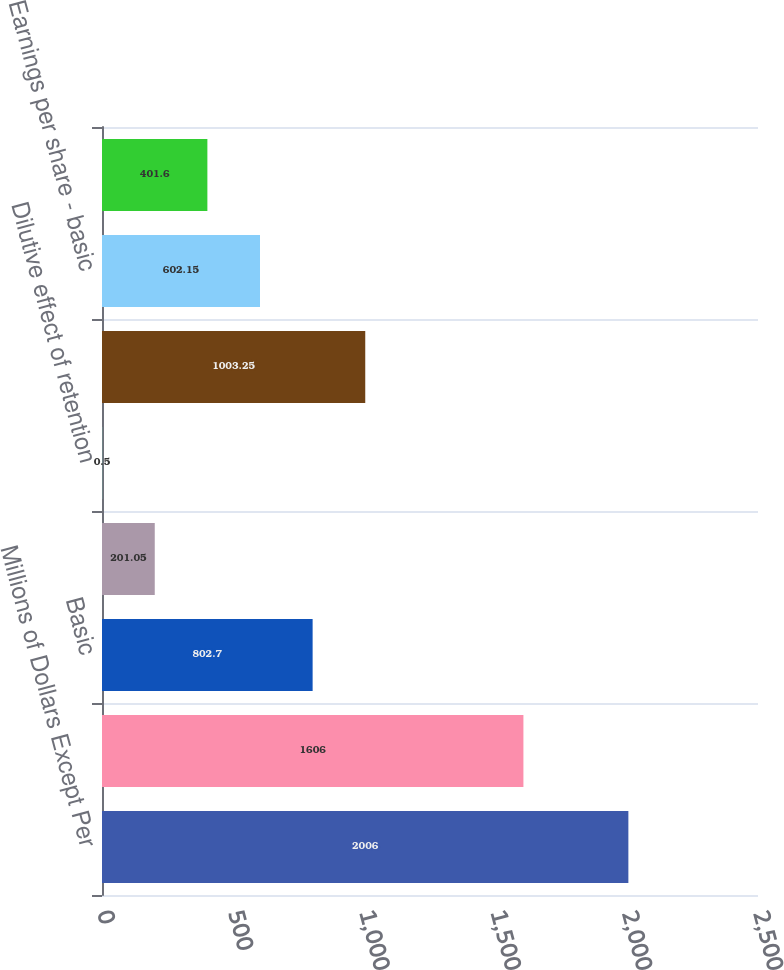<chart> <loc_0><loc_0><loc_500><loc_500><bar_chart><fcel>Millions of Dollars Except Per<fcel>Net income<fcel>Basic<fcel>Dilutive effect of stock<fcel>Dilutive effect of retention<fcel>Diluted<fcel>Earnings per share - basic<fcel>Earnings per share - diluted<nl><fcel>2006<fcel>1606<fcel>802.7<fcel>201.05<fcel>0.5<fcel>1003.25<fcel>602.15<fcel>401.6<nl></chart> 